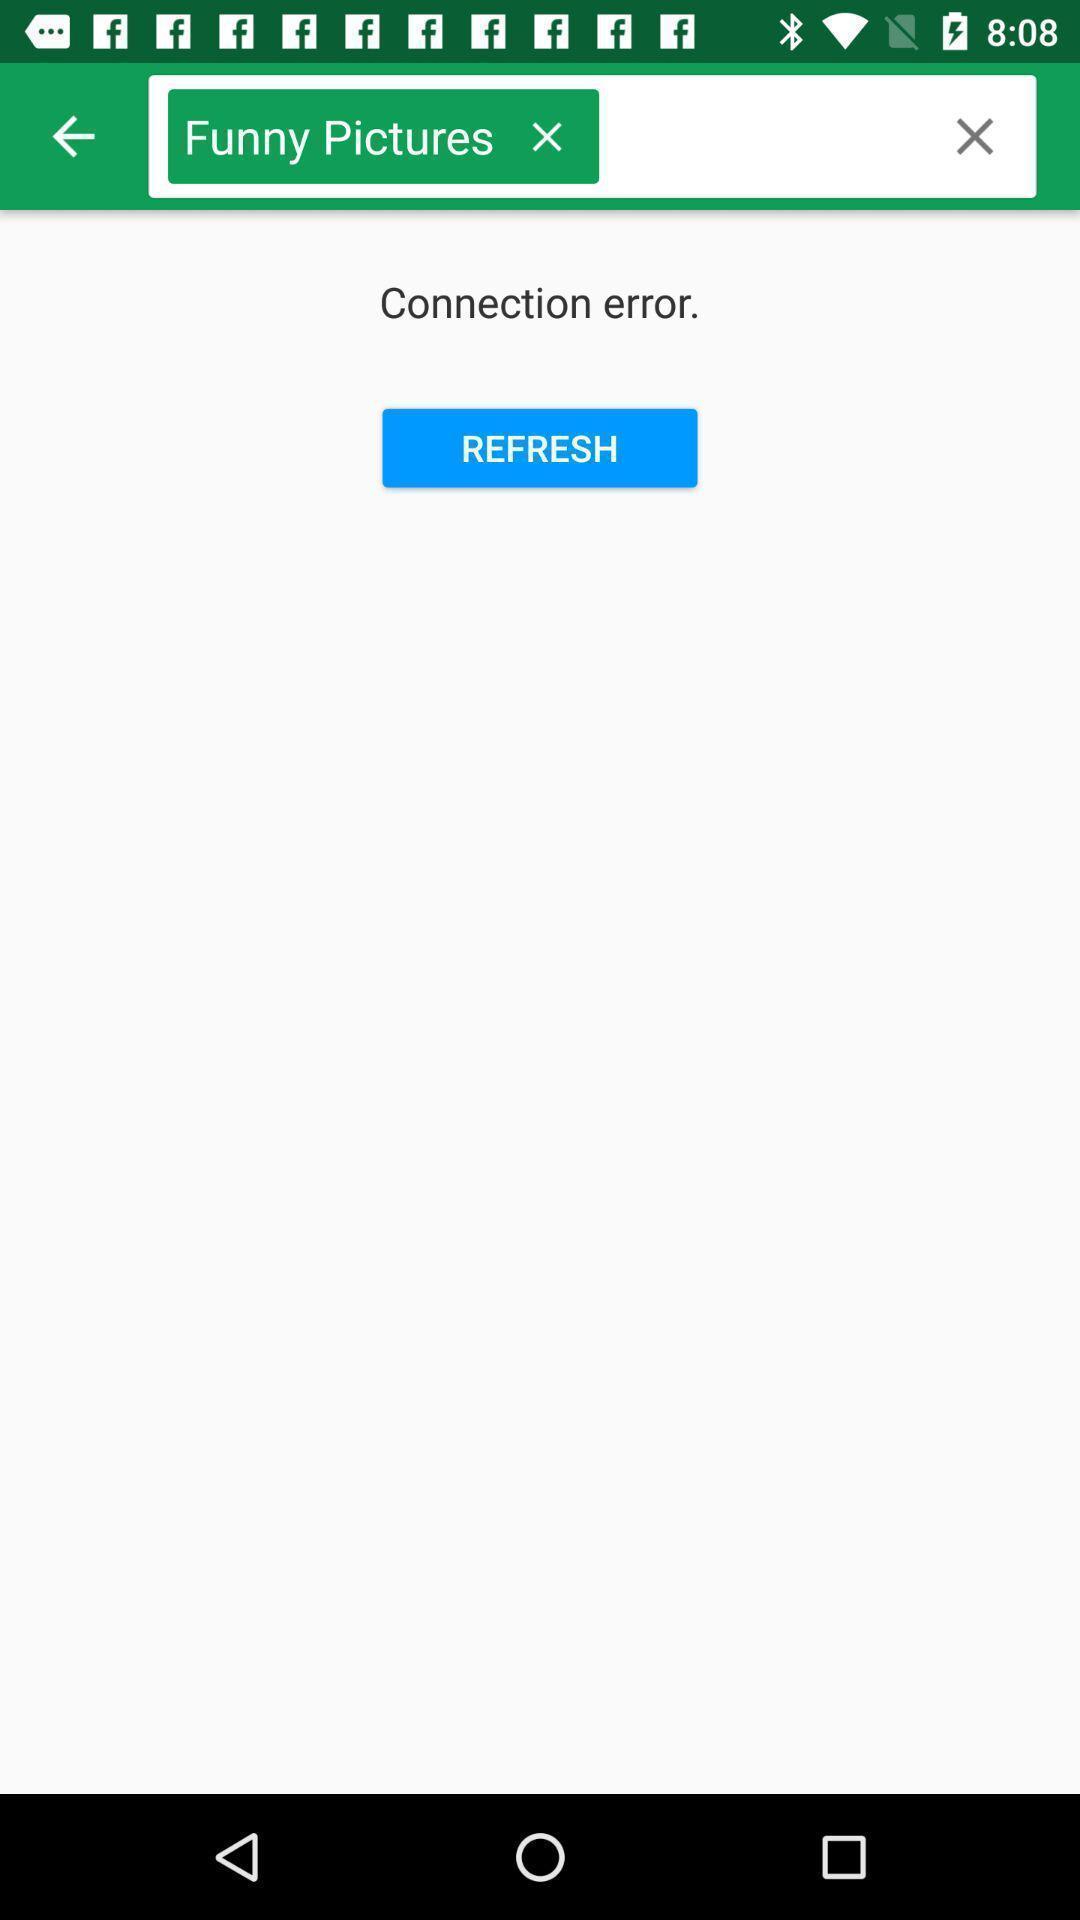Describe the key features of this screenshot. Screen shows search option. 